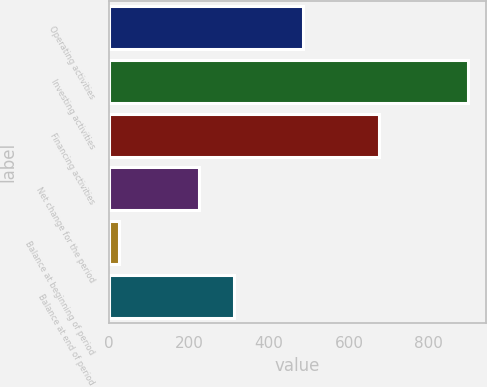Convert chart. <chart><loc_0><loc_0><loc_500><loc_500><bar_chart><fcel>Operating activities<fcel>Investing activities<fcel>Financing activities<fcel>Net change for the period<fcel>Balance at beginning of period<fcel>Balance at end of period<nl><fcel>485.9<fcel>898<fcel>676<fcel>224<fcel>25<fcel>311.3<nl></chart> 